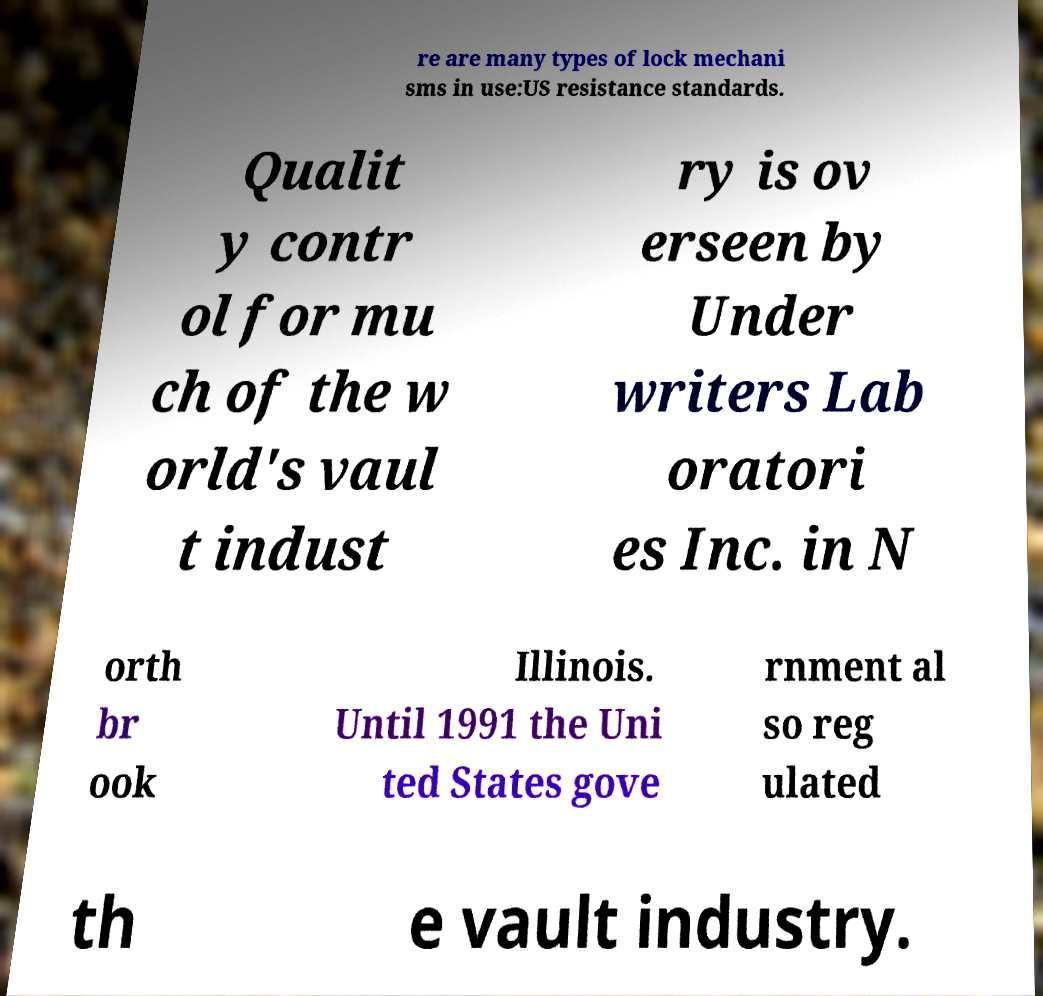Can you read and provide the text displayed in the image?This photo seems to have some interesting text. Can you extract and type it out for me? re are many types of lock mechani sms in use:US resistance standards. Qualit y contr ol for mu ch of the w orld's vaul t indust ry is ov erseen by Under writers Lab oratori es Inc. in N orth br ook Illinois. Until 1991 the Uni ted States gove rnment al so reg ulated th e vault industry. 